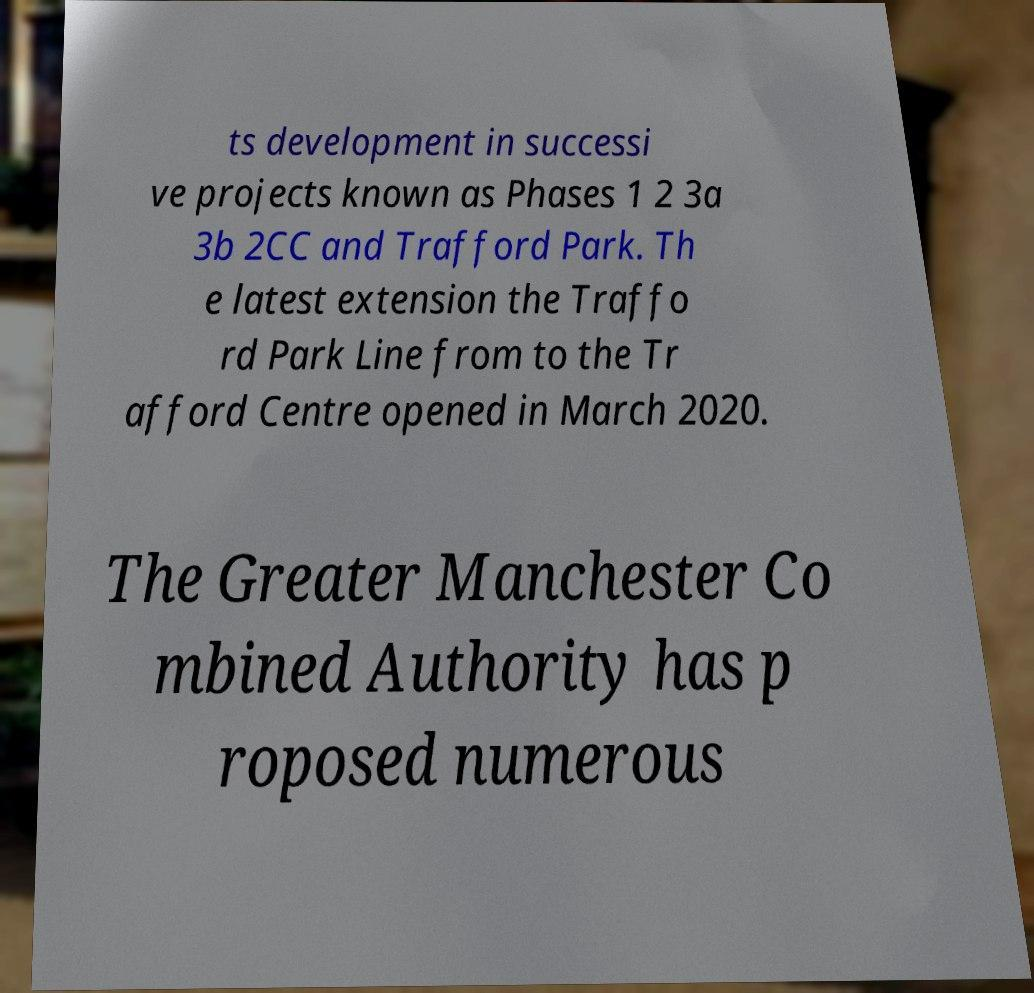What messages or text are displayed in this image? I need them in a readable, typed format. ts development in successi ve projects known as Phases 1 2 3a 3b 2CC and Trafford Park. Th e latest extension the Traffo rd Park Line from to the Tr afford Centre opened in March 2020. The Greater Manchester Co mbined Authority has p roposed numerous 